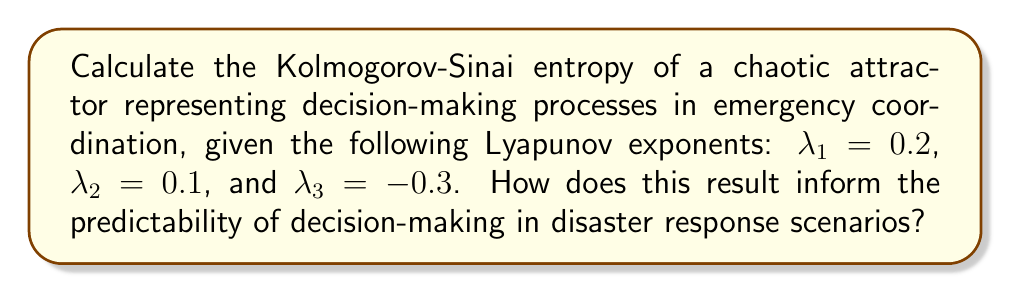Show me your answer to this math problem. To calculate the Kolmogorov-Sinai (KS) entropy of a chaotic attractor, we follow these steps:

1. The KS entropy is defined as the sum of all positive Lyapunov exponents:

   $$h_{KS} = \sum_{\lambda_i > 0} \lambda_i$$

2. Identify the positive Lyapunov exponents:
   $\lambda_1 = 0.2 > 0$
   $\lambda_2 = 0.1 > 0$
   $\lambda_3 = -0.3 < 0$ (not included in the sum)

3. Sum the positive Lyapunov exponents:

   $$h_{KS} = \lambda_1 + \lambda_2 = 0.2 + 0.1 = 0.3$$

4. Interpretation for disaster response:
   The positive KS entropy (0.3) indicates that the decision-making process in emergency coordination is chaotic. This means:
   
   a) The system is sensitive to initial conditions, implying that small changes in initial decisions can lead to significantly different outcomes.
   
   b) Long-term prediction of specific decisions becomes increasingly difficult over time.
   
   c) The rate of information production (or loss of predictability) is 0.3 bits per unit time, suggesting a moderate level of complexity in the decision-making process.

   d) Disaster response coordinators should focus on short-term predictions and adaptable strategies rather than rigid long-term plans.
Answer: $h_{KS} = 0.3$ 